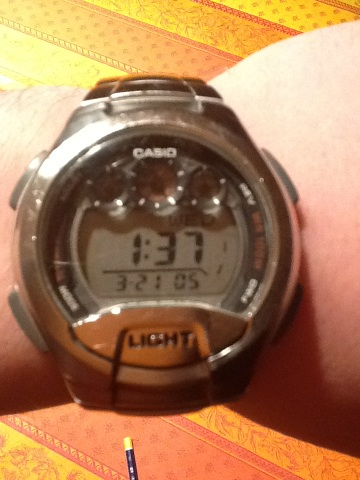Can you tell me more about the watch in the image? The watch shown in the image is a Casio digital wristwatch. It features a clear digital display, a stopwatch function judging by the layout, and likely includes features typically found on such watches like an alarm and a back-light, as indicated by the 'LIGHT' label on the button. 